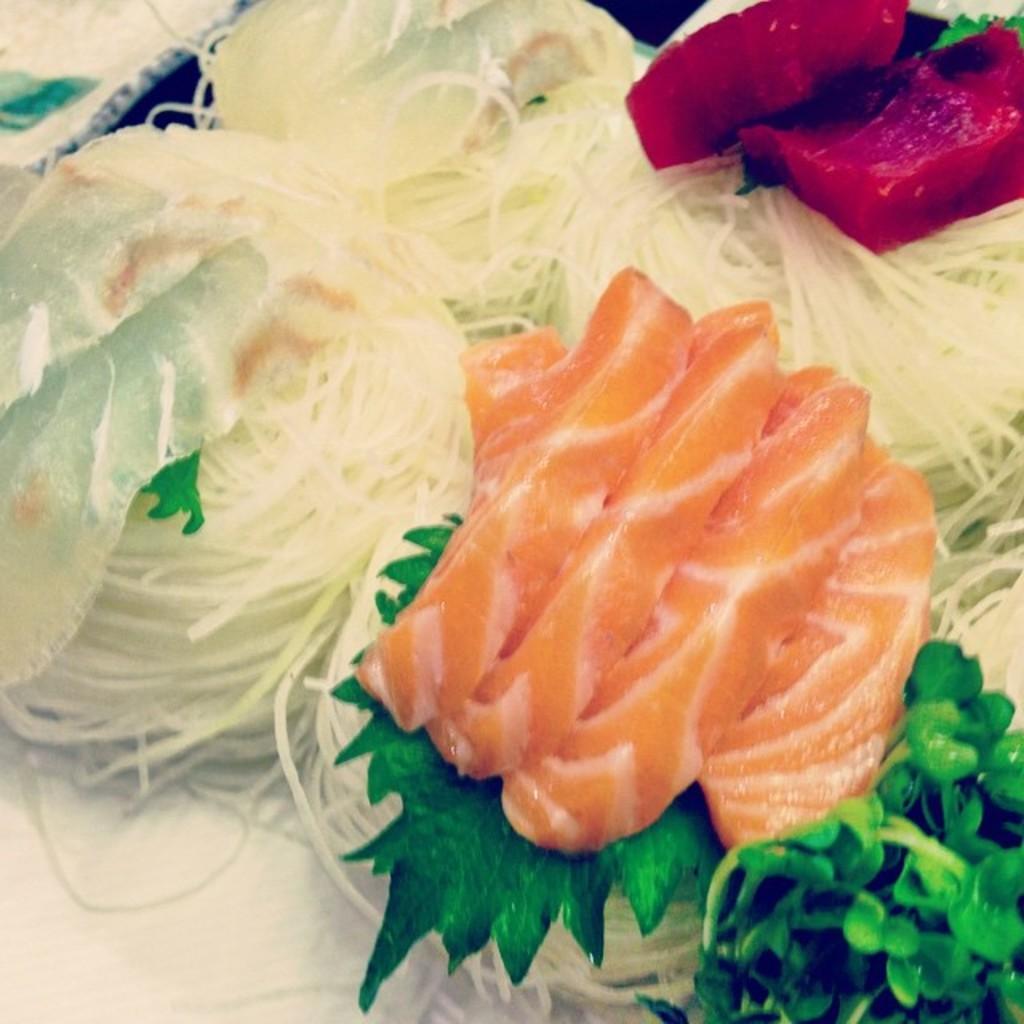Please provide a concise description of this image. In this image we can see food item. At the bottom of the image there is tissue. 